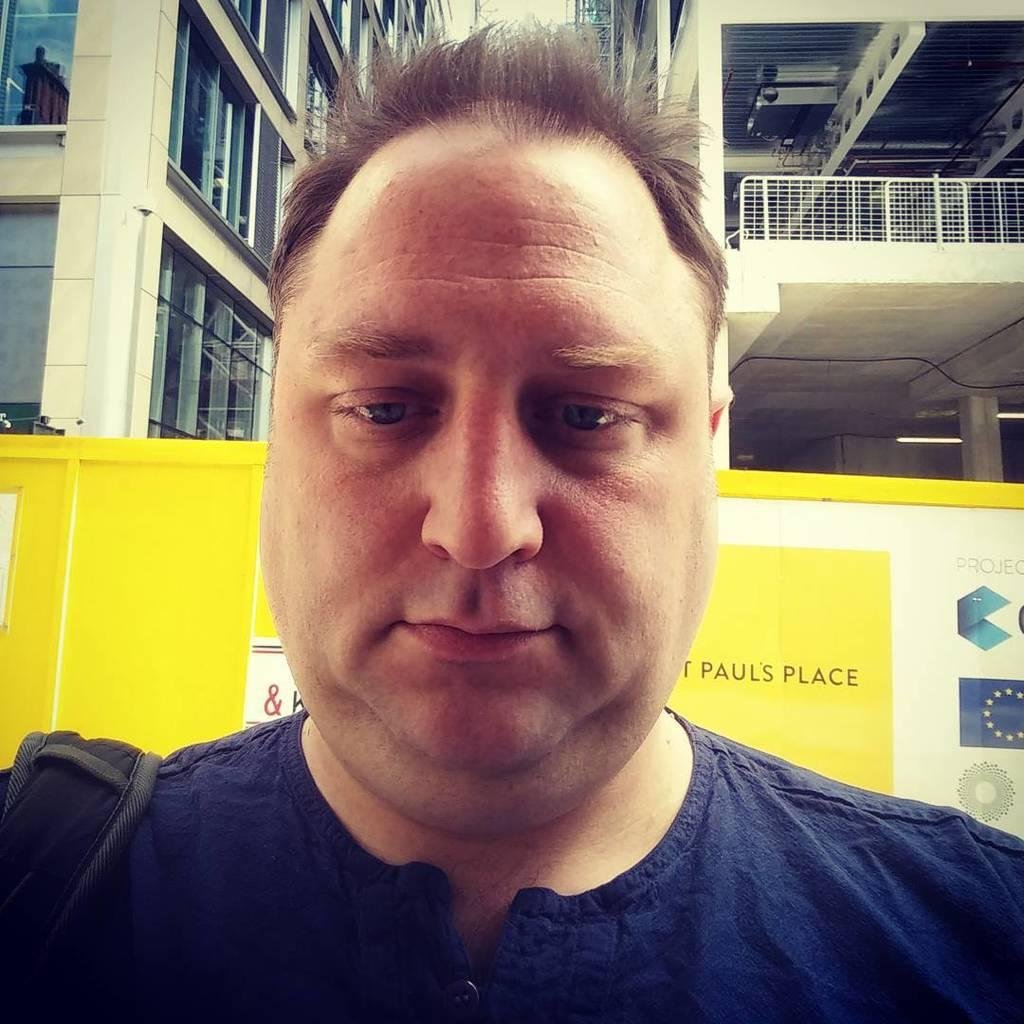Who is present in the image? There is a man in the image. What can be seen in the background of the image? There is a banner, buildings, and a railing in the background of the image. What type of leather is being used to cover the tank in the image? There is no tank present in the image, and therefore no leather covering it. 